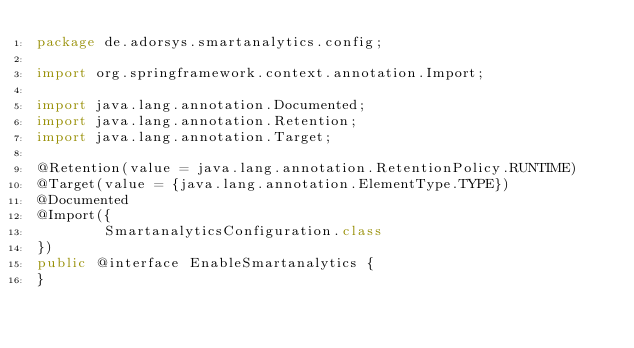Convert code to text. <code><loc_0><loc_0><loc_500><loc_500><_Java_>package de.adorsys.smartanalytics.config;

import org.springframework.context.annotation.Import;

import java.lang.annotation.Documented;
import java.lang.annotation.Retention;
import java.lang.annotation.Target;

@Retention(value = java.lang.annotation.RetentionPolicy.RUNTIME)
@Target(value = {java.lang.annotation.ElementType.TYPE})
@Documented
@Import({
        SmartanalyticsConfiguration.class
})
public @interface EnableSmartanalytics {
}
</code> 